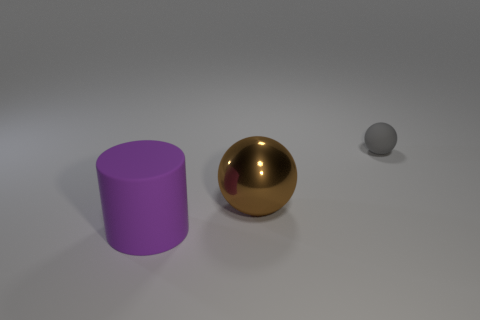What sort of environment do these objects appear to be in? The objects are placed in a neutral setting with a plain, light grey background that provides an unobstructed view of their forms and colors. It looks like a controlled setting, possibly for display or photographic purposes, rather than a natural or everyday environment. 